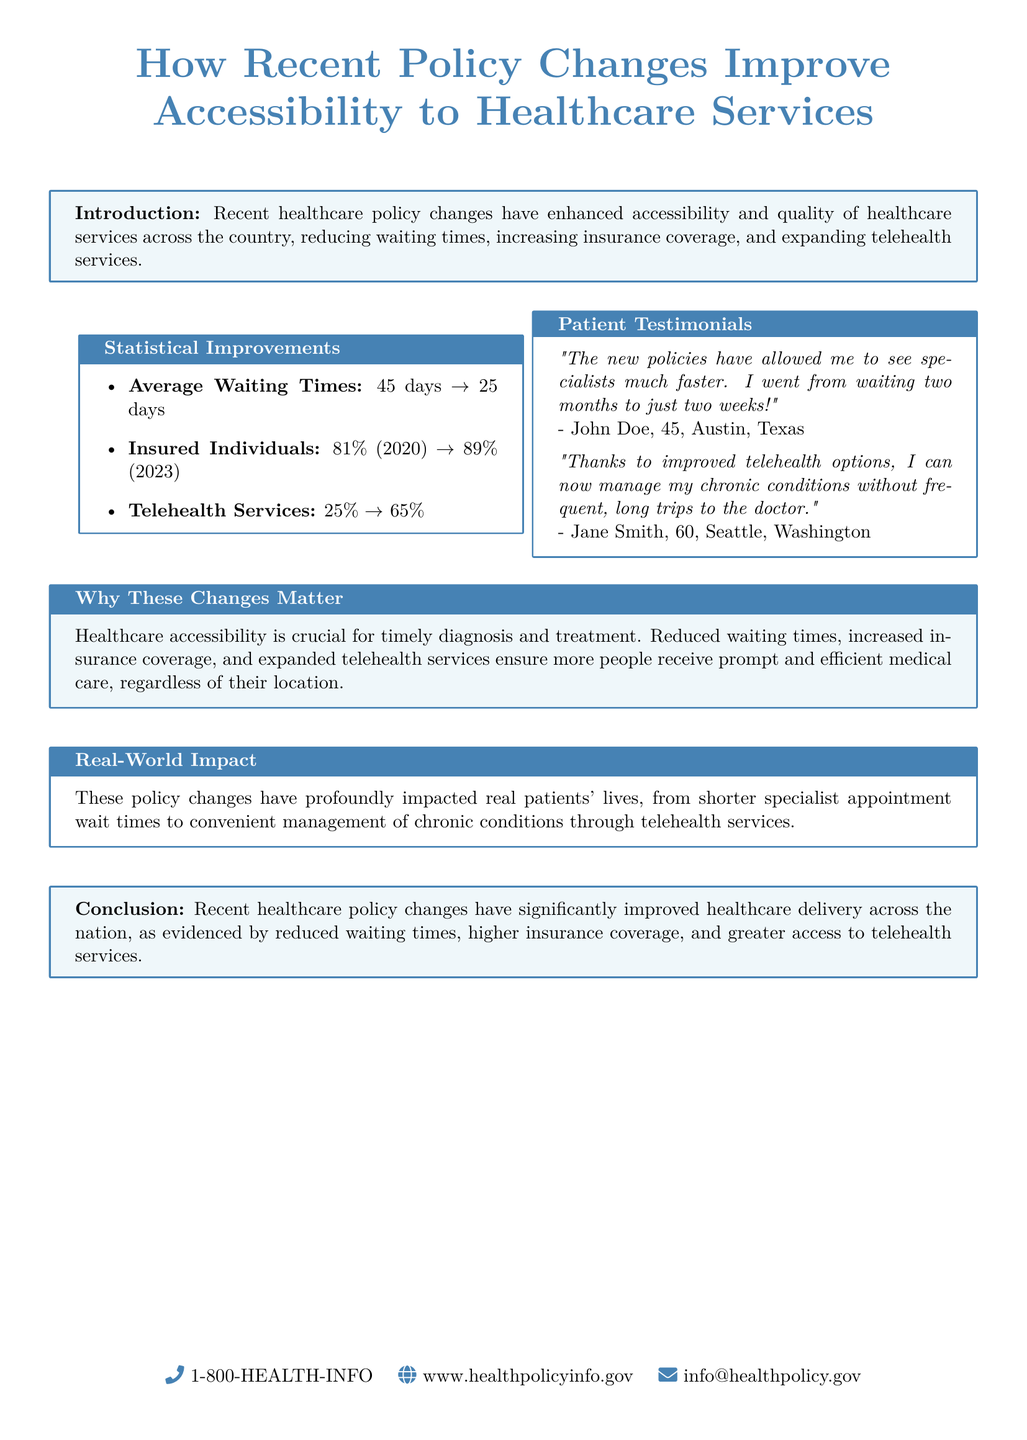What is the average waiting time after policy changes? The document states that the average waiting time has decreased from 45 days to 25 days after policy changes.
Answer: 25 days What percentage of insured individuals did change from 2020 to 2023? The document details that the percentage of insured individuals increased from 81% in 2020 to 89% in 2023, indicating a change of 8%.
Answer: 8% What is the reported increase in telehealth services? The document indicates that telehealth services increased from 25% to 65% following the recent policy changes.
Answer: 40% Why are reduced waiting times significant? The document emphasizes that reduced waiting times are crucial for timely diagnosis and treatment, thus highlighting the importance of quick access to healthcare.
Answer: Timely diagnosis and treatment Who said they can now manage conditions without frequent trips to the doctor? The document contains a testimonial from Jane Smith, who mentions that improved telehealth options allow her to manage her chronic conditions without frequent doctor visits.
Answer: Jane Smith What does the introduction emphasize about recent policy changes? The introduction highlights that recent healthcare policy changes have enhanced accessibility and quality of healthcare services.
Answer: Enhanced accessibility and quality What is the main conclusion of the document regarding healthcare delivery? The conclusion summarizes that recent healthcare policy changes have significantly improved healthcare delivery nationwide.
Answer: Improved healthcare delivery nationwide 